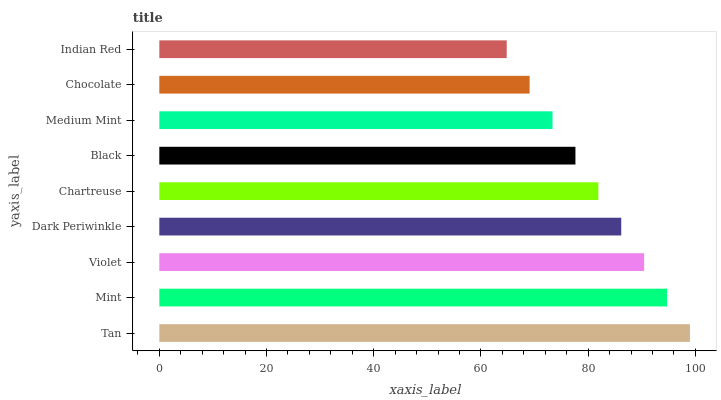Is Indian Red the minimum?
Answer yes or no. Yes. Is Tan the maximum?
Answer yes or no. Yes. Is Mint the minimum?
Answer yes or no. No. Is Mint the maximum?
Answer yes or no. No. Is Tan greater than Mint?
Answer yes or no. Yes. Is Mint less than Tan?
Answer yes or no. Yes. Is Mint greater than Tan?
Answer yes or no. No. Is Tan less than Mint?
Answer yes or no. No. Is Chartreuse the high median?
Answer yes or no. Yes. Is Chartreuse the low median?
Answer yes or no. Yes. Is Violet the high median?
Answer yes or no. No. Is Tan the low median?
Answer yes or no. No. 